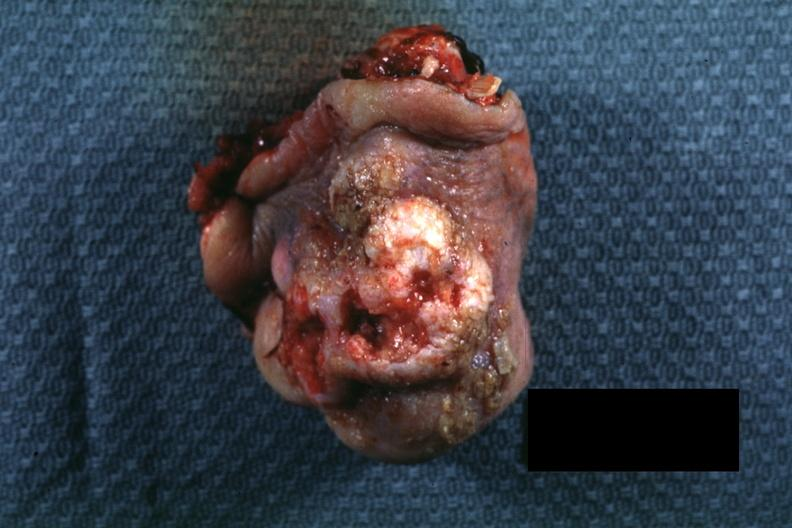does this image show portion of nose typical exophytic lesion with heaped-up margins and central ulceration?
Answer the question using a single word or phrase. Yes 